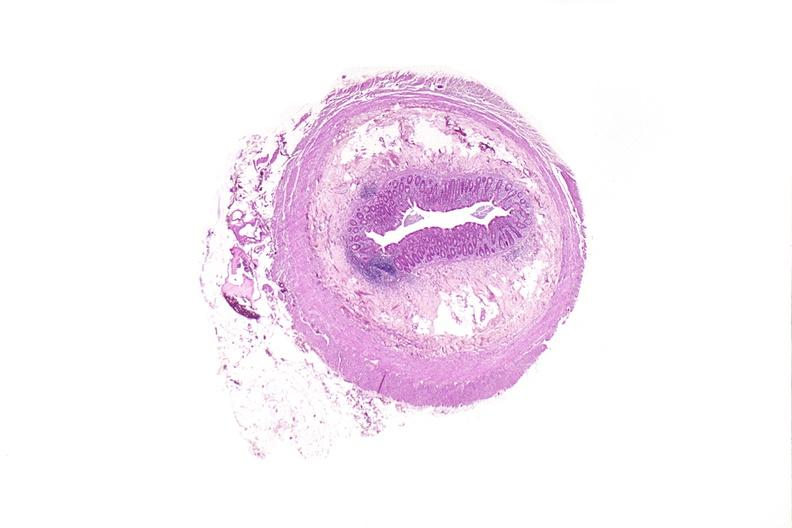what does this image show?
Answer the question using a single word or phrase. Appendix 